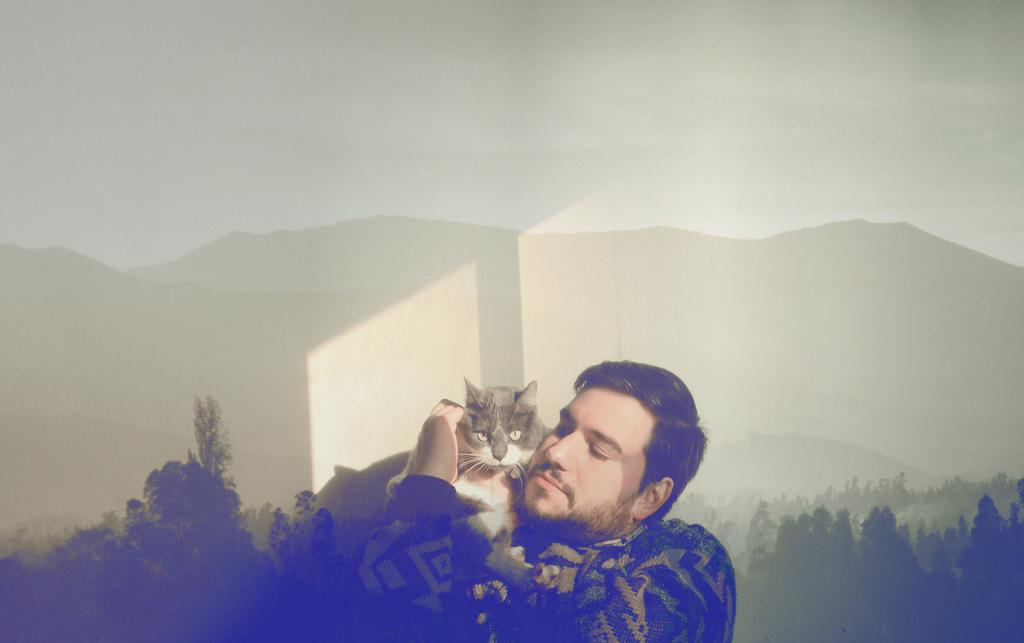Who is in the image? There is a man in the image. What is the man holding? The man is holding a cat. Where is the cat positioned in relation to the man? The cat is on the man's hands. What can be seen in the background of the image? There are trees and mountains in the background of the image. What is visible at the top of the image? The sky is visible at the top of the image. What type of adjustment can be seen on the man's neck in the image? There is no adjustment visible on the man's neck in the image. What type of ray is emitting from the cat's eyes in the image? There are no rays emitting from the cat's eyes in the image. 